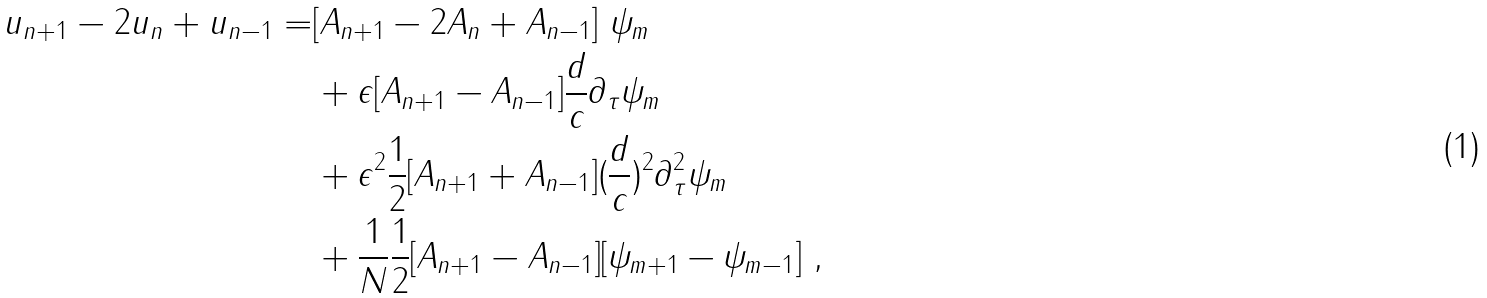Convert formula to latex. <formula><loc_0><loc_0><loc_500><loc_500>u _ { n + 1 } - 2 u _ { n } + u _ { n - 1 } = & [ A _ { n + 1 } - 2 A _ { n } + A _ { n - 1 } ] \ \psi _ { m } \\ & + \epsilon [ A _ { n + 1 } - A _ { n - 1 } ] \frac { d } { c } \partial _ { \tau } \psi _ { m } \\ & + \epsilon ^ { 2 } \frac { 1 } { 2 } [ A _ { n + 1 } + A _ { n - 1 } ] ( \frac { d } { c } ) ^ { 2 } \partial _ { \tau } ^ { 2 } \psi _ { m } \\ & + \frac { 1 } { N } \frac { 1 } { 2 } [ A _ { n + 1 } - A _ { n - 1 } ] [ \psi _ { m + 1 } - \psi _ { m - 1 } ] \ ,</formula> 